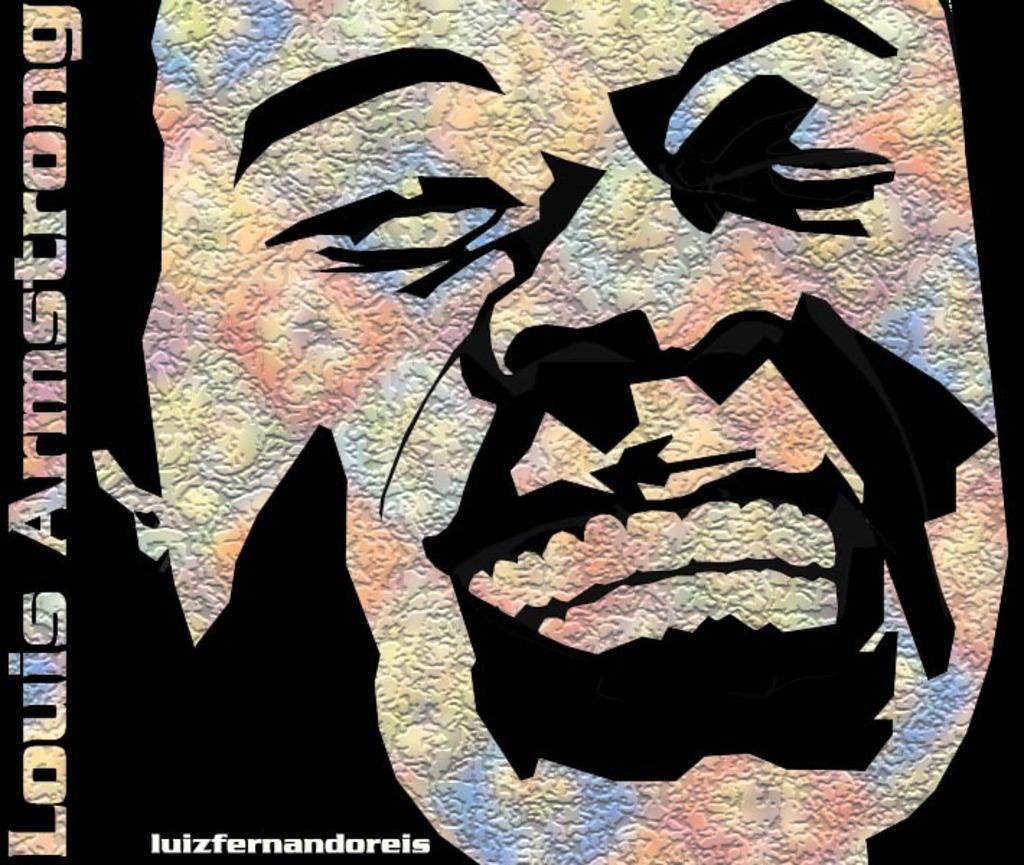In one or two sentences, can you explain what this image depicts? In this image I can see a depiction picture where I can see a face of a person. I can also see something is written on the left side and on the bottom left side of the image. 